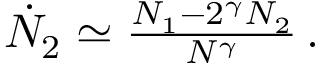Convert formula to latex. <formula><loc_0><loc_0><loc_500><loc_500>\begin{array} { r } { \dot { N } _ { 2 } \simeq \frac { N _ { 1 } - 2 ^ { \gamma } N _ { 2 } } { N ^ { \gamma } } \, . } \end{array}</formula> 